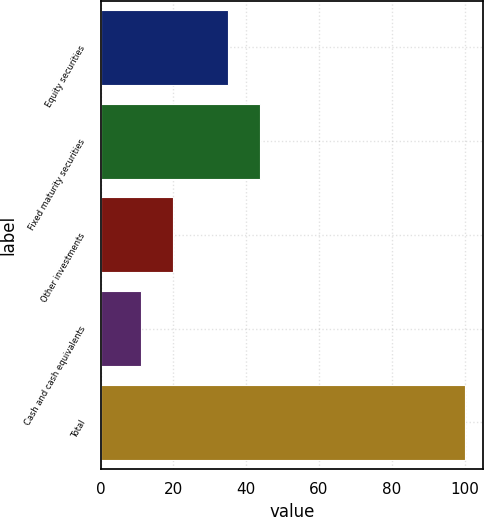<chart> <loc_0><loc_0><loc_500><loc_500><bar_chart><fcel>Equity securities<fcel>Fixed maturity securities<fcel>Other investments<fcel>Cash and cash equivalents<fcel>Total<nl><fcel>35<fcel>43.9<fcel>19.9<fcel>11<fcel>100<nl></chart> 